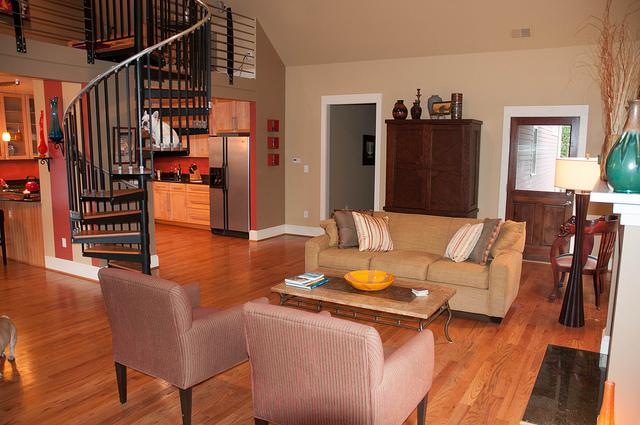What gives the square items on the couch their shape?

Choices:
A) stuffing
B) glass
C) plastic
D) styrofoam stuffing 